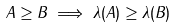Convert formula to latex. <formula><loc_0><loc_0><loc_500><loc_500>A \geq B \implies \lambda ( A ) \geq \lambda ( B )</formula> 